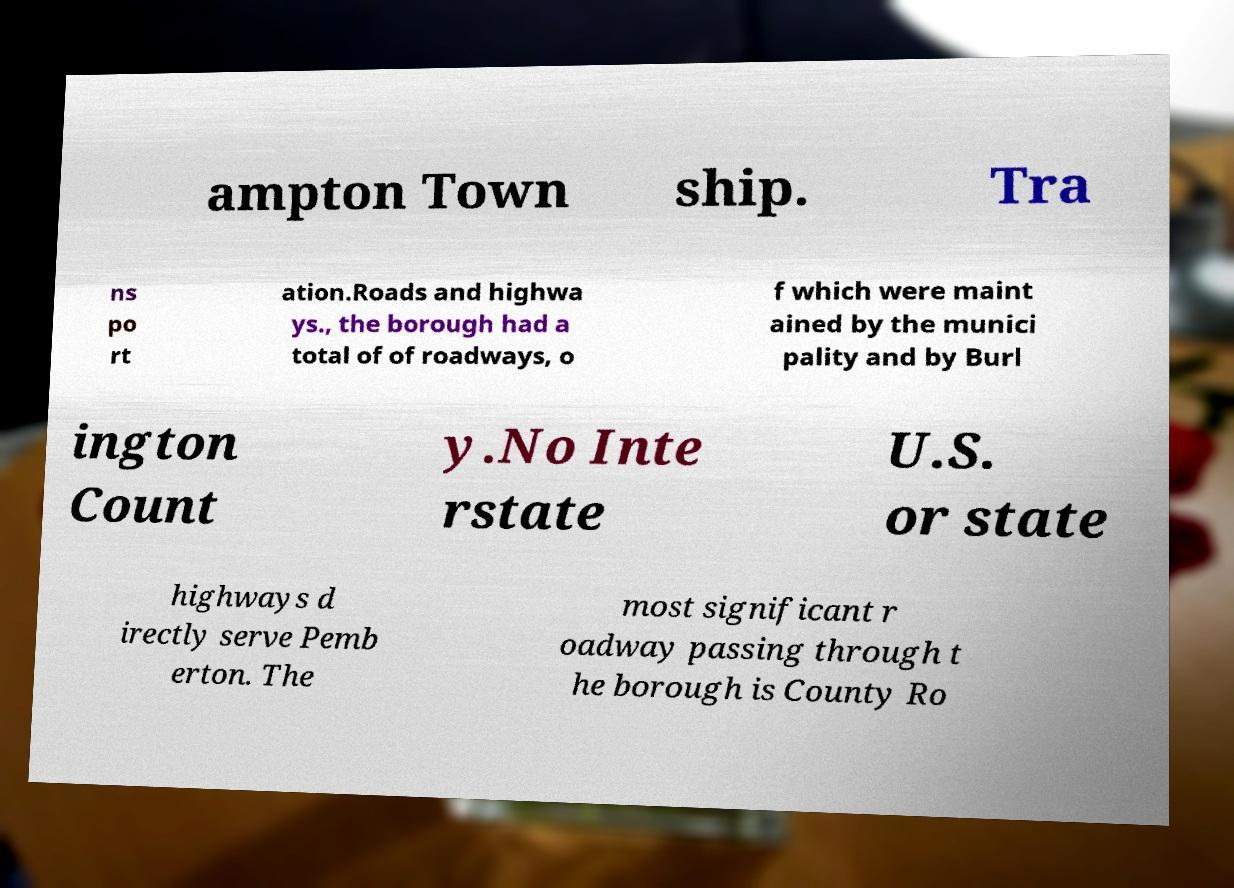I need the written content from this picture converted into text. Can you do that? ampton Town ship. Tra ns po rt ation.Roads and highwa ys., the borough had a total of of roadways, o f which were maint ained by the munici pality and by Burl ington Count y.No Inte rstate U.S. or state highways d irectly serve Pemb erton. The most significant r oadway passing through t he borough is County Ro 